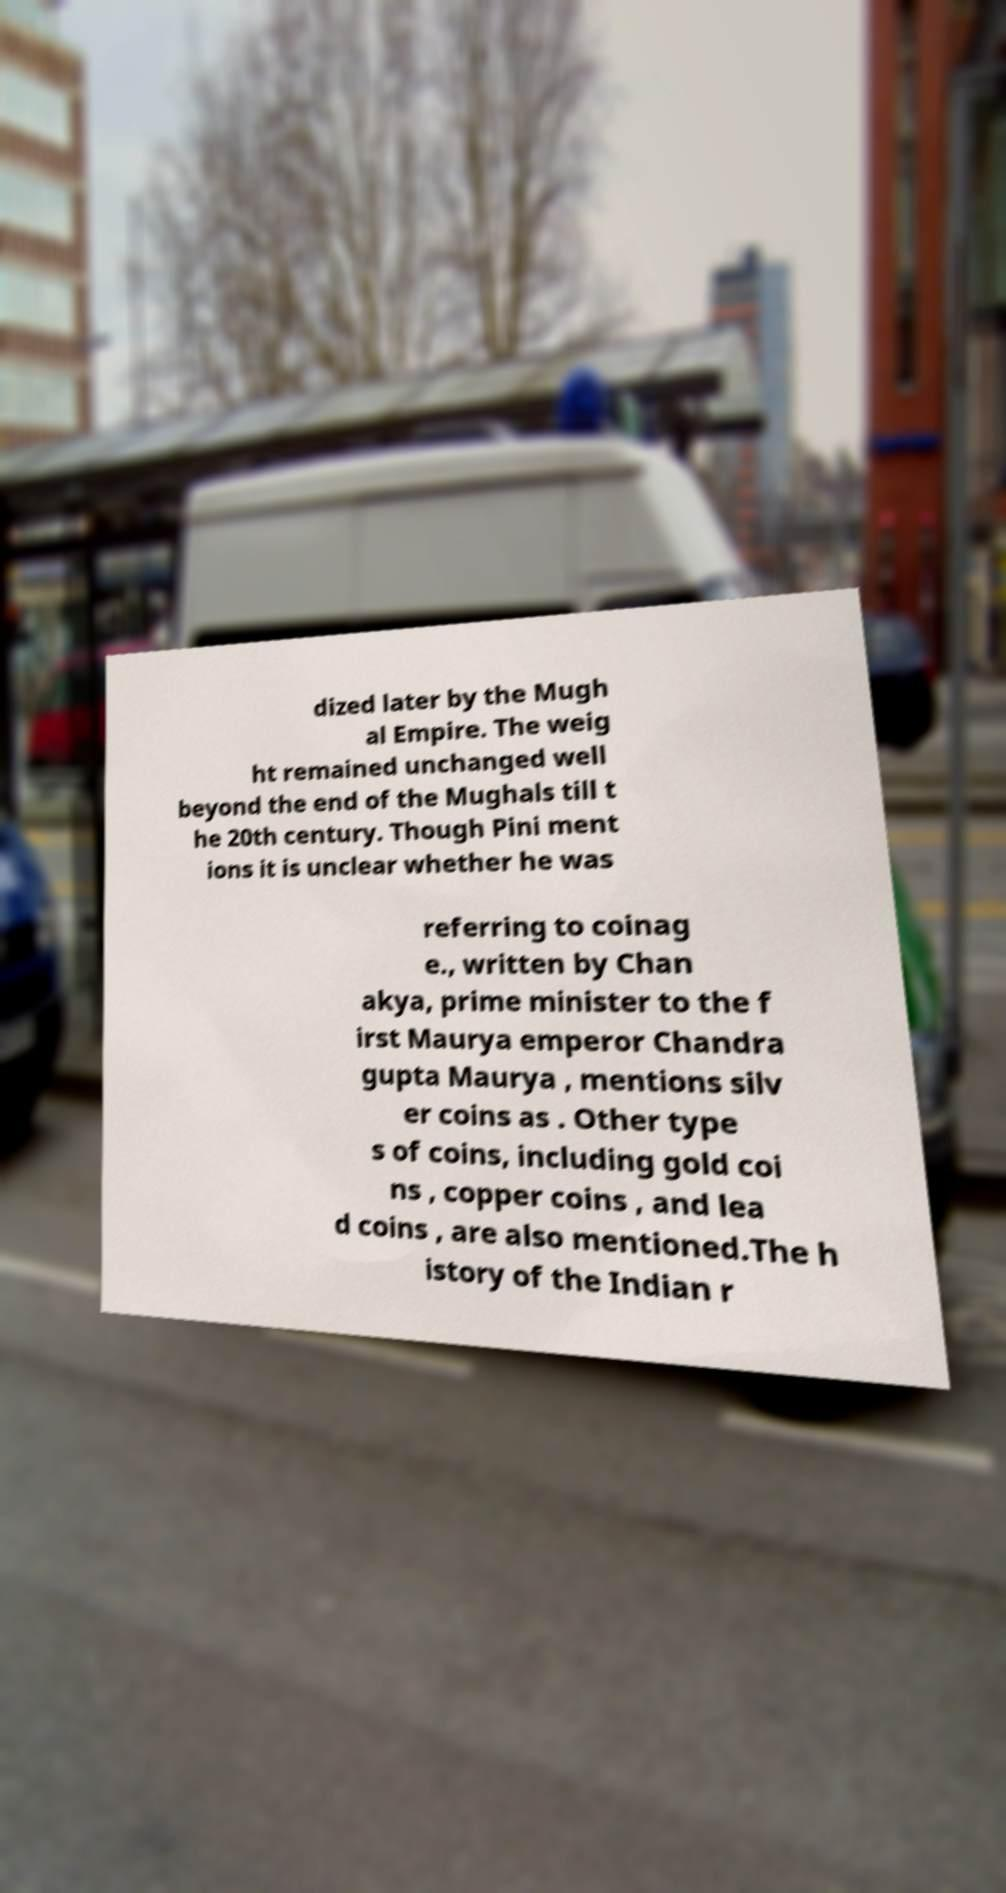Can you read and provide the text displayed in the image?This photo seems to have some interesting text. Can you extract and type it out for me? dized later by the Mugh al Empire. The weig ht remained unchanged well beyond the end of the Mughals till t he 20th century. Though Pini ment ions it is unclear whether he was referring to coinag e., written by Chan akya, prime minister to the f irst Maurya emperor Chandra gupta Maurya , mentions silv er coins as . Other type s of coins, including gold coi ns , copper coins , and lea d coins , are also mentioned.The h istory of the Indian r 